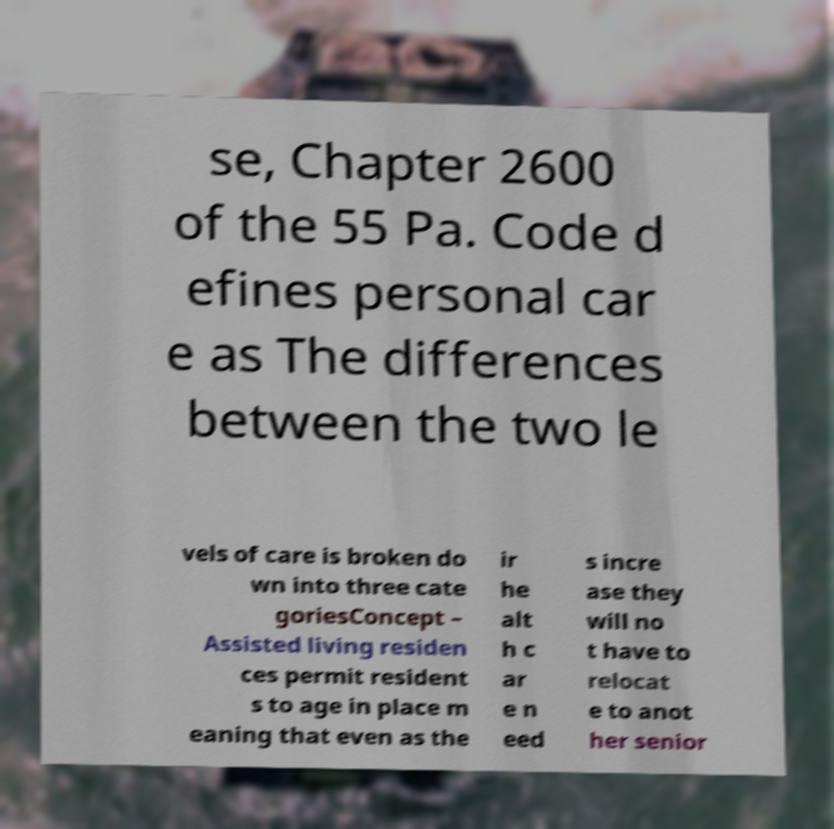Could you assist in decoding the text presented in this image and type it out clearly? se, Chapter 2600 of the 55 Pa. Code d efines personal car e as The differences between the two le vels of care is broken do wn into three cate goriesConcept – Assisted living residen ces permit resident s to age in place m eaning that even as the ir he alt h c ar e n eed s incre ase they will no t have to relocat e to anot her senior 